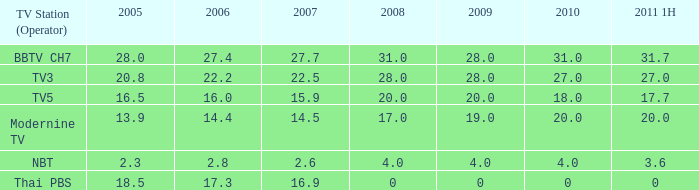What is the number of 2008 values having a 2006 under 17.3, 2010 over 4, and 2011 1H of 20? 1.0. 